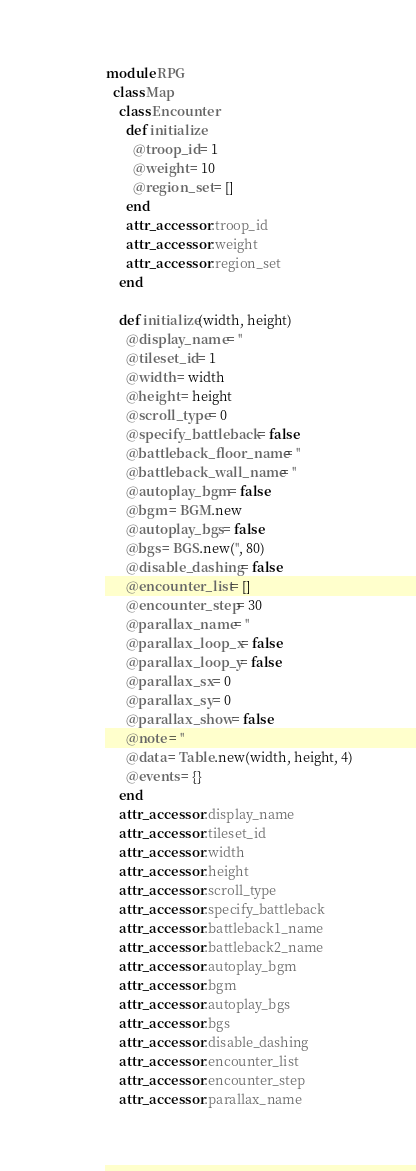Convert code to text. <code><loc_0><loc_0><loc_500><loc_500><_Ruby_>
module RPG
  class Map
    class Encounter
      def initialize
        @troop_id = 1
        @weight = 10
        @region_set = []
      end
      attr_accessor :troop_id
      attr_accessor :weight
      attr_accessor :region_set
    end

    def initialize(width, height)
      @display_name = ''
      @tileset_id = 1
      @width = width
      @height = height
      @scroll_type = 0
      @specify_battleback = false
      @battleback_floor_name = ''
      @battleback_wall_name = ''
      @autoplay_bgm = false
      @bgm = BGM.new
      @autoplay_bgs = false
      @bgs = BGS.new('', 80)
      @disable_dashing = false
      @encounter_list = []
      @encounter_step = 30
      @parallax_name = ''
      @parallax_loop_x = false
      @parallax_loop_y = false
      @parallax_sx = 0
      @parallax_sy = 0
      @parallax_show = false
      @note = ''
      @data = Table.new(width, height, 4)
      @events = {}
    end
    attr_accessor :display_name
    attr_accessor :tileset_id
    attr_accessor :width
    attr_accessor :height
    attr_accessor :scroll_type
    attr_accessor :specify_battleback
    attr_accessor :battleback1_name
    attr_accessor :battleback2_name
    attr_accessor :autoplay_bgm
    attr_accessor :bgm
    attr_accessor :autoplay_bgs
    attr_accessor :bgs
    attr_accessor :disable_dashing
    attr_accessor :encounter_list
    attr_accessor :encounter_step
    attr_accessor :parallax_name</code> 